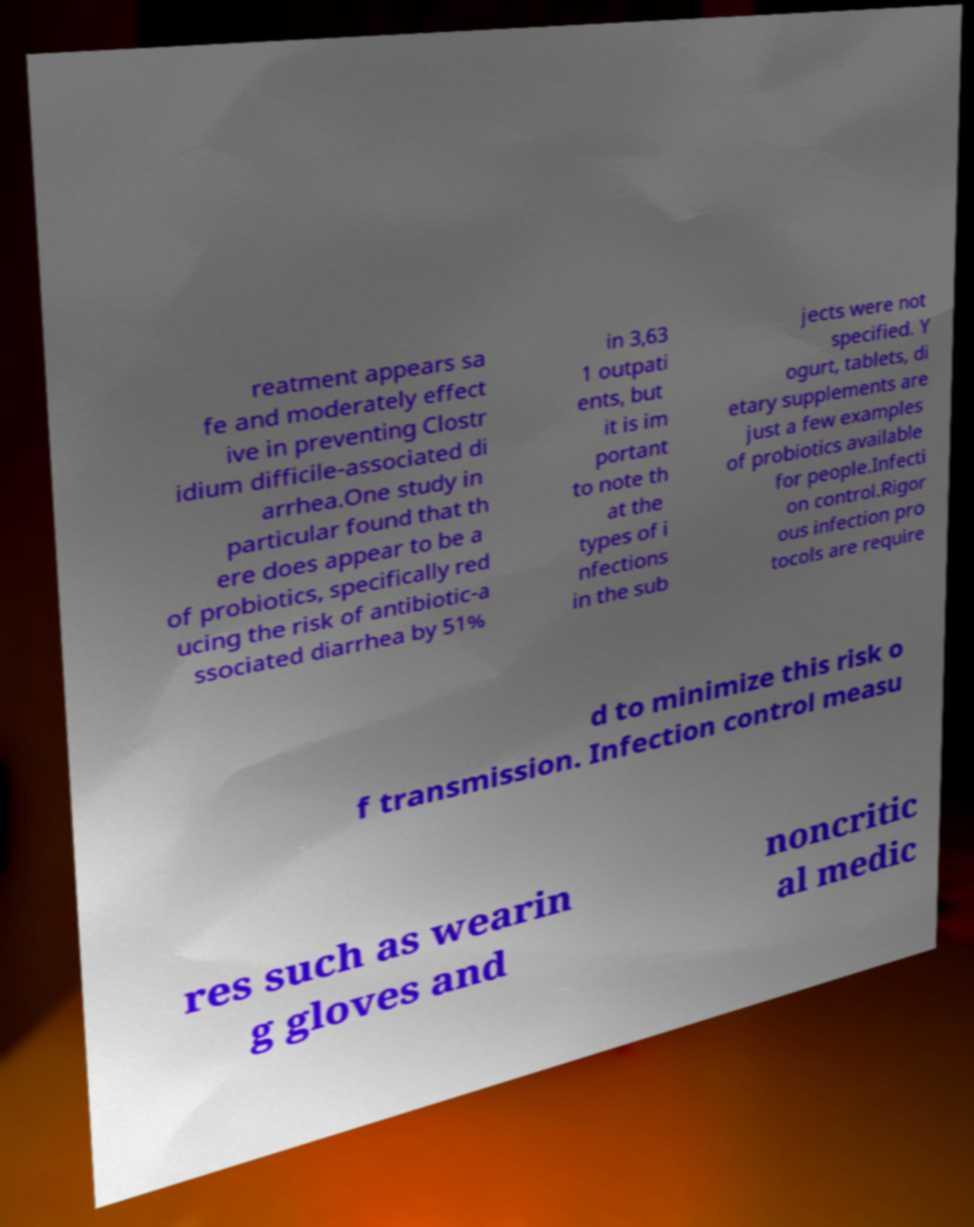What messages or text are displayed in this image? I need them in a readable, typed format. reatment appears sa fe and moderately effect ive in preventing Clostr idium difficile-associated di arrhea.One study in particular found that th ere does appear to be a of probiotics, specifically red ucing the risk of antibiotic-a ssociated diarrhea by 51% in 3,63 1 outpati ents, but it is im portant to note th at the types of i nfections in the sub jects were not specified. Y ogurt, tablets, di etary supplements are just a few examples of probiotics available for people.Infecti on control.Rigor ous infection pro tocols are require d to minimize this risk o f transmission. Infection control measu res such as wearin g gloves and noncritic al medic 